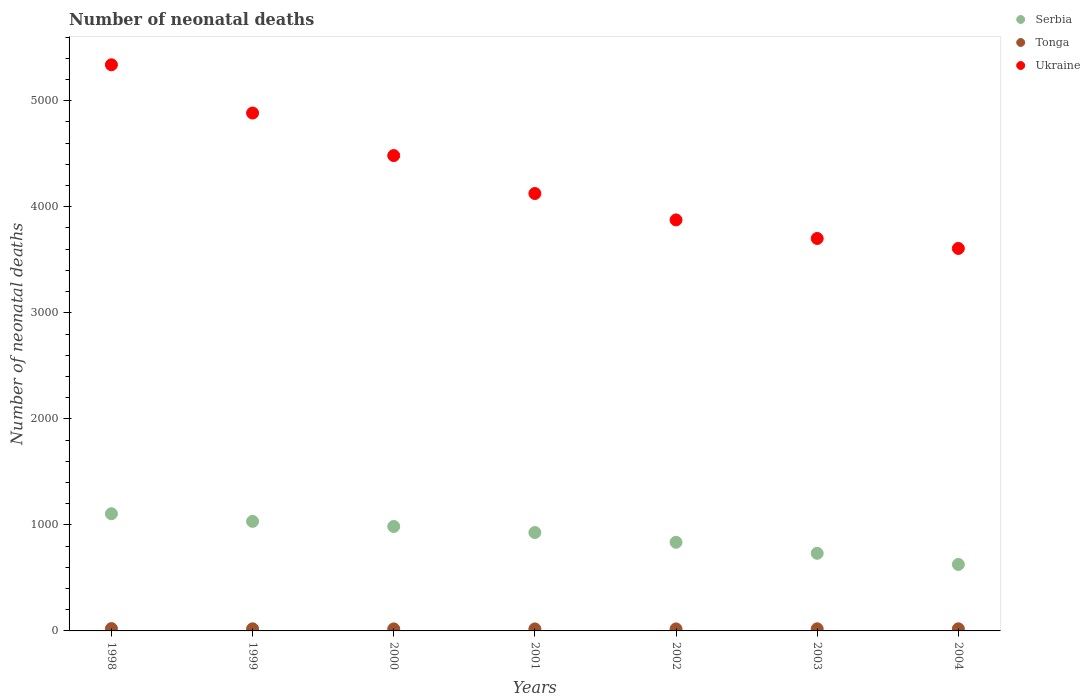How many different coloured dotlines are there?
Your answer should be very brief. 3. What is the number of neonatal deaths in in Serbia in 2001?
Your response must be concise. 928. Across all years, what is the maximum number of neonatal deaths in in Tonga?
Provide a short and direct response. 22. Across all years, what is the minimum number of neonatal deaths in in Tonga?
Offer a very short reply. 19. In which year was the number of neonatal deaths in in Ukraine maximum?
Give a very brief answer. 1998. In which year was the number of neonatal deaths in in Tonga minimum?
Your response must be concise. 2000. What is the total number of neonatal deaths in in Ukraine in the graph?
Ensure brevity in your answer.  3.00e+04. What is the difference between the number of neonatal deaths in in Ukraine in 1998 and the number of neonatal deaths in in Tonga in 2002?
Give a very brief answer. 5320. What is the average number of neonatal deaths in in Tonga per year?
Offer a very short reply. 19.86. In the year 1998, what is the difference between the number of neonatal deaths in in Tonga and number of neonatal deaths in in Serbia?
Your answer should be compact. -1083. Is the difference between the number of neonatal deaths in in Tonga in 1998 and 1999 greater than the difference between the number of neonatal deaths in in Serbia in 1998 and 1999?
Give a very brief answer. No. What is the difference between the highest and the second highest number of neonatal deaths in in Serbia?
Provide a short and direct response. 72. What is the difference between the highest and the lowest number of neonatal deaths in in Serbia?
Make the answer very short. 478. Is the number of neonatal deaths in in Serbia strictly greater than the number of neonatal deaths in in Ukraine over the years?
Ensure brevity in your answer.  No. How many dotlines are there?
Give a very brief answer. 3. How many years are there in the graph?
Your answer should be compact. 7. Are the values on the major ticks of Y-axis written in scientific E-notation?
Provide a short and direct response. No. Where does the legend appear in the graph?
Give a very brief answer. Top right. What is the title of the graph?
Keep it short and to the point. Number of neonatal deaths. Does "Lower middle income" appear as one of the legend labels in the graph?
Your answer should be compact. No. What is the label or title of the Y-axis?
Your response must be concise. Number of neonatal deaths. What is the Number of neonatal deaths of Serbia in 1998?
Offer a terse response. 1105. What is the Number of neonatal deaths of Ukraine in 1998?
Your answer should be very brief. 5339. What is the Number of neonatal deaths of Serbia in 1999?
Give a very brief answer. 1033. What is the Number of neonatal deaths of Tonga in 1999?
Keep it short and to the point. 20. What is the Number of neonatal deaths in Ukraine in 1999?
Your answer should be very brief. 4884. What is the Number of neonatal deaths of Serbia in 2000?
Offer a terse response. 985. What is the Number of neonatal deaths of Ukraine in 2000?
Provide a short and direct response. 4483. What is the Number of neonatal deaths in Serbia in 2001?
Keep it short and to the point. 928. What is the Number of neonatal deaths in Ukraine in 2001?
Offer a very short reply. 4125. What is the Number of neonatal deaths of Serbia in 2002?
Your response must be concise. 836. What is the Number of neonatal deaths of Tonga in 2002?
Your answer should be very brief. 19. What is the Number of neonatal deaths in Ukraine in 2002?
Offer a very short reply. 3876. What is the Number of neonatal deaths in Serbia in 2003?
Offer a terse response. 732. What is the Number of neonatal deaths of Tonga in 2003?
Keep it short and to the point. 20. What is the Number of neonatal deaths of Ukraine in 2003?
Ensure brevity in your answer.  3701. What is the Number of neonatal deaths in Serbia in 2004?
Your answer should be very brief. 627. What is the Number of neonatal deaths of Ukraine in 2004?
Keep it short and to the point. 3607. Across all years, what is the maximum Number of neonatal deaths of Serbia?
Your response must be concise. 1105. Across all years, what is the maximum Number of neonatal deaths of Tonga?
Make the answer very short. 22. Across all years, what is the maximum Number of neonatal deaths in Ukraine?
Ensure brevity in your answer.  5339. Across all years, what is the minimum Number of neonatal deaths of Serbia?
Ensure brevity in your answer.  627. Across all years, what is the minimum Number of neonatal deaths in Tonga?
Make the answer very short. 19. Across all years, what is the minimum Number of neonatal deaths in Ukraine?
Make the answer very short. 3607. What is the total Number of neonatal deaths of Serbia in the graph?
Provide a short and direct response. 6246. What is the total Number of neonatal deaths in Tonga in the graph?
Your answer should be very brief. 139. What is the total Number of neonatal deaths of Ukraine in the graph?
Make the answer very short. 3.00e+04. What is the difference between the Number of neonatal deaths of Ukraine in 1998 and that in 1999?
Make the answer very short. 455. What is the difference between the Number of neonatal deaths in Serbia in 1998 and that in 2000?
Provide a succinct answer. 120. What is the difference between the Number of neonatal deaths in Tonga in 1998 and that in 2000?
Offer a very short reply. 3. What is the difference between the Number of neonatal deaths in Ukraine in 1998 and that in 2000?
Offer a very short reply. 856. What is the difference between the Number of neonatal deaths of Serbia in 1998 and that in 2001?
Make the answer very short. 177. What is the difference between the Number of neonatal deaths in Ukraine in 1998 and that in 2001?
Your answer should be very brief. 1214. What is the difference between the Number of neonatal deaths in Serbia in 1998 and that in 2002?
Keep it short and to the point. 269. What is the difference between the Number of neonatal deaths in Tonga in 1998 and that in 2002?
Keep it short and to the point. 3. What is the difference between the Number of neonatal deaths of Ukraine in 1998 and that in 2002?
Ensure brevity in your answer.  1463. What is the difference between the Number of neonatal deaths of Serbia in 1998 and that in 2003?
Your answer should be very brief. 373. What is the difference between the Number of neonatal deaths in Tonga in 1998 and that in 2003?
Give a very brief answer. 2. What is the difference between the Number of neonatal deaths of Ukraine in 1998 and that in 2003?
Give a very brief answer. 1638. What is the difference between the Number of neonatal deaths of Serbia in 1998 and that in 2004?
Keep it short and to the point. 478. What is the difference between the Number of neonatal deaths in Ukraine in 1998 and that in 2004?
Offer a very short reply. 1732. What is the difference between the Number of neonatal deaths of Serbia in 1999 and that in 2000?
Give a very brief answer. 48. What is the difference between the Number of neonatal deaths in Ukraine in 1999 and that in 2000?
Offer a very short reply. 401. What is the difference between the Number of neonatal deaths of Serbia in 1999 and that in 2001?
Keep it short and to the point. 105. What is the difference between the Number of neonatal deaths of Tonga in 1999 and that in 2001?
Ensure brevity in your answer.  1. What is the difference between the Number of neonatal deaths in Ukraine in 1999 and that in 2001?
Keep it short and to the point. 759. What is the difference between the Number of neonatal deaths in Serbia in 1999 and that in 2002?
Your answer should be compact. 197. What is the difference between the Number of neonatal deaths in Tonga in 1999 and that in 2002?
Your response must be concise. 1. What is the difference between the Number of neonatal deaths of Ukraine in 1999 and that in 2002?
Keep it short and to the point. 1008. What is the difference between the Number of neonatal deaths of Serbia in 1999 and that in 2003?
Provide a short and direct response. 301. What is the difference between the Number of neonatal deaths in Tonga in 1999 and that in 2003?
Provide a succinct answer. 0. What is the difference between the Number of neonatal deaths in Ukraine in 1999 and that in 2003?
Offer a very short reply. 1183. What is the difference between the Number of neonatal deaths in Serbia in 1999 and that in 2004?
Keep it short and to the point. 406. What is the difference between the Number of neonatal deaths in Tonga in 1999 and that in 2004?
Keep it short and to the point. 0. What is the difference between the Number of neonatal deaths in Ukraine in 1999 and that in 2004?
Give a very brief answer. 1277. What is the difference between the Number of neonatal deaths in Serbia in 2000 and that in 2001?
Give a very brief answer. 57. What is the difference between the Number of neonatal deaths in Tonga in 2000 and that in 2001?
Provide a succinct answer. 0. What is the difference between the Number of neonatal deaths of Ukraine in 2000 and that in 2001?
Provide a short and direct response. 358. What is the difference between the Number of neonatal deaths in Serbia in 2000 and that in 2002?
Provide a short and direct response. 149. What is the difference between the Number of neonatal deaths of Ukraine in 2000 and that in 2002?
Your answer should be compact. 607. What is the difference between the Number of neonatal deaths of Serbia in 2000 and that in 2003?
Offer a terse response. 253. What is the difference between the Number of neonatal deaths of Tonga in 2000 and that in 2003?
Your response must be concise. -1. What is the difference between the Number of neonatal deaths in Ukraine in 2000 and that in 2003?
Provide a short and direct response. 782. What is the difference between the Number of neonatal deaths of Serbia in 2000 and that in 2004?
Ensure brevity in your answer.  358. What is the difference between the Number of neonatal deaths in Ukraine in 2000 and that in 2004?
Your answer should be very brief. 876. What is the difference between the Number of neonatal deaths in Serbia in 2001 and that in 2002?
Your answer should be very brief. 92. What is the difference between the Number of neonatal deaths in Tonga in 2001 and that in 2002?
Your answer should be very brief. 0. What is the difference between the Number of neonatal deaths in Ukraine in 2001 and that in 2002?
Give a very brief answer. 249. What is the difference between the Number of neonatal deaths in Serbia in 2001 and that in 2003?
Give a very brief answer. 196. What is the difference between the Number of neonatal deaths in Ukraine in 2001 and that in 2003?
Make the answer very short. 424. What is the difference between the Number of neonatal deaths of Serbia in 2001 and that in 2004?
Keep it short and to the point. 301. What is the difference between the Number of neonatal deaths of Ukraine in 2001 and that in 2004?
Offer a terse response. 518. What is the difference between the Number of neonatal deaths in Serbia in 2002 and that in 2003?
Your answer should be very brief. 104. What is the difference between the Number of neonatal deaths of Ukraine in 2002 and that in 2003?
Provide a succinct answer. 175. What is the difference between the Number of neonatal deaths of Serbia in 2002 and that in 2004?
Give a very brief answer. 209. What is the difference between the Number of neonatal deaths in Ukraine in 2002 and that in 2004?
Offer a very short reply. 269. What is the difference between the Number of neonatal deaths of Serbia in 2003 and that in 2004?
Give a very brief answer. 105. What is the difference between the Number of neonatal deaths of Tonga in 2003 and that in 2004?
Provide a short and direct response. 0. What is the difference between the Number of neonatal deaths of Ukraine in 2003 and that in 2004?
Provide a short and direct response. 94. What is the difference between the Number of neonatal deaths in Serbia in 1998 and the Number of neonatal deaths in Tonga in 1999?
Keep it short and to the point. 1085. What is the difference between the Number of neonatal deaths of Serbia in 1998 and the Number of neonatal deaths of Ukraine in 1999?
Provide a short and direct response. -3779. What is the difference between the Number of neonatal deaths of Tonga in 1998 and the Number of neonatal deaths of Ukraine in 1999?
Ensure brevity in your answer.  -4862. What is the difference between the Number of neonatal deaths of Serbia in 1998 and the Number of neonatal deaths of Tonga in 2000?
Make the answer very short. 1086. What is the difference between the Number of neonatal deaths in Serbia in 1998 and the Number of neonatal deaths in Ukraine in 2000?
Your answer should be compact. -3378. What is the difference between the Number of neonatal deaths in Tonga in 1998 and the Number of neonatal deaths in Ukraine in 2000?
Keep it short and to the point. -4461. What is the difference between the Number of neonatal deaths of Serbia in 1998 and the Number of neonatal deaths of Tonga in 2001?
Make the answer very short. 1086. What is the difference between the Number of neonatal deaths in Serbia in 1998 and the Number of neonatal deaths in Ukraine in 2001?
Provide a short and direct response. -3020. What is the difference between the Number of neonatal deaths of Tonga in 1998 and the Number of neonatal deaths of Ukraine in 2001?
Provide a short and direct response. -4103. What is the difference between the Number of neonatal deaths of Serbia in 1998 and the Number of neonatal deaths of Tonga in 2002?
Make the answer very short. 1086. What is the difference between the Number of neonatal deaths of Serbia in 1998 and the Number of neonatal deaths of Ukraine in 2002?
Your answer should be compact. -2771. What is the difference between the Number of neonatal deaths of Tonga in 1998 and the Number of neonatal deaths of Ukraine in 2002?
Give a very brief answer. -3854. What is the difference between the Number of neonatal deaths in Serbia in 1998 and the Number of neonatal deaths in Tonga in 2003?
Your answer should be compact. 1085. What is the difference between the Number of neonatal deaths in Serbia in 1998 and the Number of neonatal deaths in Ukraine in 2003?
Offer a terse response. -2596. What is the difference between the Number of neonatal deaths in Tonga in 1998 and the Number of neonatal deaths in Ukraine in 2003?
Your answer should be very brief. -3679. What is the difference between the Number of neonatal deaths of Serbia in 1998 and the Number of neonatal deaths of Tonga in 2004?
Provide a succinct answer. 1085. What is the difference between the Number of neonatal deaths of Serbia in 1998 and the Number of neonatal deaths of Ukraine in 2004?
Keep it short and to the point. -2502. What is the difference between the Number of neonatal deaths in Tonga in 1998 and the Number of neonatal deaths in Ukraine in 2004?
Your answer should be very brief. -3585. What is the difference between the Number of neonatal deaths in Serbia in 1999 and the Number of neonatal deaths in Tonga in 2000?
Keep it short and to the point. 1014. What is the difference between the Number of neonatal deaths in Serbia in 1999 and the Number of neonatal deaths in Ukraine in 2000?
Make the answer very short. -3450. What is the difference between the Number of neonatal deaths in Tonga in 1999 and the Number of neonatal deaths in Ukraine in 2000?
Offer a terse response. -4463. What is the difference between the Number of neonatal deaths of Serbia in 1999 and the Number of neonatal deaths of Tonga in 2001?
Keep it short and to the point. 1014. What is the difference between the Number of neonatal deaths of Serbia in 1999 and the Number of neonatal deaths of Ukraine in 2001?
Offer a very short reply. -3092. What is the difference between the Number of neonatal deaths of Tonga in 1999 and the Number of neonatal deaths of Ukraine in 2001?
Offer a very short reply. -4105. What is the difference between the Number of neonatal deaths in Serbia in 1999 and the Number of neonatal deaths in Tonga in 2002?
Provide a succinct answer. 1014. What is the difference between the Number of neonatal deaths of Serbia in 1999 and the Number of neonatal deaths of Ukraine in 2002?
Make the answer very short. -2843. What is the difference between the Number of neonatal deaths of Tonga in 1999 and the Number of neonatal deaths of Ukraine in 2002?
Offer a very short reply. -3856. What is the difference between the Number of neonatal deaths of Serbia in 1999 and the Number of neonatal deaths of Tonga in 2003?
Ensure brevity in your answer.  1013. What is the difference between the Number of neonatal deaths in Serbia in 1999 and the Number of neonatal deaths in Ukraine in 2003?
Provide a short and direct response. -2668. What is the difference between the Number of neonatal deaths in Tonga in 1999 and the Number of neonatal deaths in Ukraine in 2003?
Provide a short and direct response. -3681. What is the difference between the Number of neonatal deaths in Serbia in 1999 and the Number of neonatal deaths in Tonga in 2004?
Keep it short and to the point. 1013. What is the difference between the Number of neonatal deaths of Serbia in 1999 and the Number of neonatal deaths of Ukraine in 2004?
Your response must be concise. -2574. What is the difference between the Number of neonatal deaths of Tonga in 1999 and the Number of neonatal deaths of Ukraine in 2004?
Provide a short and direct response. -3587. What is the difference between the Number of neonatal deaths of Serbia in 2000 and the Number of neonatal deaths of Tonga in 2001?
Provide a succinct answer. 966. What is the difference between the Number of neonatal deaths in Serbia in 2000 and the Number of neonatal deaths in Ukraine in 2001?
Keep it short and to the point. -3140. What is the difference between the Number of neonatal deaths in Tonga in 2000 and the Number of neonatal deaths in Ukraine in 2001?
Ensure brevity in your answer.  -4106. What is the difference between the Number of neonatal deaths in Serbia in 2000 and the Number of neonatal deaths in Tonga in 2002?
Keep it short and to the point. 966. What is the difference between the Number of neonatal deaths of Serbia in 2000 and the Number of neonatal deaths of Ukraine in 2002?
Give a very brief answer. -2891. What is the difference between the Number of neonatal deaths of Tonga in 2000 and the Number of neonatal deaths of Ukraine in 2002?
Offer a terse response. -3857. What is the difference between the Number of neonatal deaths of Serbia in 2000 and the Number of neonatal deaths of Tonga in 2003?
Ensure brevity in your answer.  965. What is the difference between the Number of neonatal deaths of Serbia in 2000 and the Number of neonatal deaths of Ukraine in 2003?
Provide a succinct answer. -2716. What is the difference between the Number of neonatal deaths of Tonga in 2000 and the Number of neonatal deaths of Ukraine in 2003?
Your answer should be compact. -3682. What is the difference between the Number of neonatal deaths of Serbia in 2000 and the Number of neonatal deaths of Tonga in 2004?
Ensure brevity in your answer.  965. What is the difference between the Number of neonatal deaths of Serbia in 2000 and the Number of neonatal deaths of Ukraine in 2004?
Offer a very short reply. -2622. What is the difference between the Number of neonatal deaths in Tonga in 2000 and the Number of neonatal deaths in Ukraine in 2004?
Your answer should be compact. -3588. What is the difference between the Number of neonatal deaths in Serbia in 2001 and the Number of neonatal deaths in Tonga in 2002?
Your answer should be compact. 909. What is the difference between the Number of neonatal deaths in Serbia in 2001 and the Number of neonatal deaths in Ukraine in 2002?
Your response must be concise. -2948. What is the difference between the Number of neonatal deaths of Tonga in 2001 and the Number of neonatal deaths of Ukraine in 2002?
Your response must be concise. -3857. What is the difference between the Number of neonatal deaths in Serbia in 2001 and the Number of neonatal deaths in Tonga in 2003?
Your response must be concise. 908. What is the difference between the Number of neonatal deaths of Serbia in 2001 and the Number of neonatal deaths of Ukraine in 2003?
Provide a succinct answer. -2773. What is the difference between the Number of neonatal deaths in Tonga in 2001 and the Number of neonatal deaths in Ukraine in 2003?
Your response must be concise. -3682. What is the difference between the Number of neonatal deaths of Serbia in 2001 and the Number of neonatal deaths of Tonga in 2004?
Offer a very short reply. 908. What is the difference between the Number of neonatal deaths of Serbia in 2001 and the Number of neonatal deaths of Ukraine in 2004?
Ensure brevity in your answer.  -2679. What is the difference between the Number of neonatal deaths in Tonga in 2001 and the Number of neonatal deaths in Ukraine in 2004?
Provide a short and direct response. -3588. What is the difference between the Number of neonatal deaths of Serbia in 2002 and the Number of neonatal deaths of Tonga in 2003?
Your answer should be very brief. 816. What is the difference between the Number of neonatal deaths in Serbia in 2002 and the Number of neonatal deaths in Ukraine in 2003?
Provide a short and direct response. -2865. What is the difference between the Number of neonatal deaths in Tonga in 2002 and the Number of neonatal deaths in Ukraine in 2003?
Provide a short and direct response. -3682. What is the difference between the Number of neonatal deaths of Serbia in 2002 and the Number of neonatal deaths of Tonga in 2004?
Your answer should be very brief. 816. What is the difference between the Number of neonatal deaths in Serbia in 2002 and the Number of neonatal deaths in Ukraine in 2004?
Offer a very short reply. -2771. What is the difference between the Number of neonatal deaths in Tonga in 2002 and the Number of neonatal deaths in Ukraine in 2004?
Provide a succinct answer. -3588. What is the difference between the Number of neonatal deaths of Serbia in 2003 and the Number of neonatal deaths of Tonga in 2004?
Provide a short and direct response. 712. What is the difference between the Number of neonatal deaths in Serbia in 2003 and the Number of neonatal deaths in Ukraine in 2004?
Your answer should be compact. -2875. What is the difference between the Number of neonatal deaths of Tonga in 2003 and the Number of neonatal deaths of Ukraine in 2004?
Your response must be concise. -3587. What is the average Number of neonatal deaths in Serbia per year?
Your response must be concise. 892.29. What is the average Number of neonatal deaths of Tonga per year?
Your response must be concise. 19.86. What is the average Number of neonatal deaths in Ukraine per year?
Your answer should be compact. 4287.86. In the year 1998, what is the difference between the Number of neonatal deaths of Serbia and Number of neonatal deaths of Tonga?
Offer a very short reply. 1083. In the year 1998, what is the difference between the Number of neonatal deaths of Serbia and Number of neonatal deaths of Ukraine?
Give a very brief answer. -4234. In the year 1998, what is the difference between the Number of neonatal deaths of Tonga and Number of neonatal deaths of Ukraine?
Provide a short and direct response. -5317. In the year 1999, what is the difference between the Number of neonatal deaths in Serbia and Number of neonatal deaths in Tonga?
Provide a short and direct response. 1013. In the year 1999, what is the difference between the Number of neonatal deaths in Serbia and Number of neonatal deaths in Ukraine?
Ensure brevity in your answer.  -3851. In the year 1999, what is the difference between the Number of neonatal deaths of Tonga and Number of neonatal deaths of Ukraine?
Ensure brevity in your answer.  -4864. In the year 2000, what is the difference between the Number of neonatal deaths of Serbia and Number of neonatal deaths of Tonga?
Your response must be concise. 966. In the year 2000, what is the difference between the Number of neonatal deaths in Serbia and Number of neonatal deaths in Ukraine?
Provide a succinct answer. -3498. In the year 2000, what is the difference between the Number of neonatal deaths in Tonga and Number of neonatal deaths in Ukraine?
Provide a succinct answer. -4464. In the year 2001, what is the difference between the Number of neonatal deaths of Serbia and Number of neonatal deaths of Tonga?
Your answer should be compact. 909. In the year 2001, what is the difference between the Number of neonatal deaths of Serbia and Number of neonatal deaths of Ukraine?
Offer a terse response. -3197. In the year 2001, what is the difference between the Number of neonatal deaths in Tonga and Number of neonatal deaths in Ukraine?
Your answer should be very brief. -4106. In the year 2002, what is the difference between the Number of neonatal deaths in Serbia and Number of neonatal deaths in Tonga?
Give a very brief answer. 817. In the year 2002, what is the difference between the Number of neonatal deaths in Serbia and Number of neonatal deaths in Ukraine?
Offer a terse response. -3040. In the year 2002, what is the difference between the Number of neonatal deaths in Tonga and Number of neonatal deaths in Ukraine?
Provide a short and direct response. -3857. In the year 2003, what is the difference between the Number of neonatal deaths in Serbia and Number of neonatal deaths in Tonga?
Your answer should be compact. 712. In the year 2003, what is the difference between the Number of neonatal deaths of Serbia and Number of neonatal deaths of Ukraine?
Give a very brief answer. -2969. In the year 2003, what is the difference between the Number of neonatal deaths of Tonga and Number of neonatal deaths of Ukraine?
Ensure brevity in your answer.  -3681. In the year 2004, what is the difference between the Number of neonatal deaths in Serbia and Number of neonatal deaths in Tonga?
Provide a succinct answer. 607. In the year 2004, what is the difference between the Number of neonatal deaths in Serbia and Number of neonatal deaths in Ukraine?
Ensure brevity in your answer.  -2980. In the year 2004, what is the difference between the Number of neonatal deaths of Tonga and Number of neonatal deaths of Ukraine?
Your answer should be compact. -3587. What is the ratio of the Number of neonatal deaths of Serbia in 1998 to that in 1999?
Offer a very short reply. 1.07. What is the ratio of the Number of neonatal deaths of Tonga in 1998 to that in 1999?
Offer a terse response. 1.1. What is the ratio of the Number of neonatal deaths of Ukraine in 1998 to that in 1999?
Provide a succinct answer. 1.09. What is the ratio of the Number of neonatal deaths in Serbia in 1998 to that in 2000?
Your response must be concise. 1.12. What is the ratio of the Number of neonatal deaths of Tonga in 1998 to that in 2000?
Provide a short and direct response. 1.16. What is the ratio of the Number of neonatal deaths of Ukraine in 1998 to that in 2000?
Give a very brief answer. 1.19. What is the ratio of the Number of neonatal deaths of Serbia in 1998 to that in 2001?
Keep it short and to the point. 1.19. What is the ratio of the Number of neonatal deaths in Tonga in 1998 to that in 2001?
Offer a very short reply. 1.16. What is the ratio of the Number of neonatal deaths in Ukraine in 1998 to that in 2001?
Keep it short and to the point. 1.29. What is the ratio of the Number of neonatal deaths in Serbia in 1998 to that in 2002?
Offer a terse response. 1.32. What is the ratio of the Number of neonatal deaths of Tonga in 1998 to that in 2002?
Give a very brief answer. 1.16. What is the ratio of the Number of neonatal deaths of Ukraine in 1998 to that in 2002?
Offer a terse response. 1.38. What is the ratio of the Number of neonatal deaths of Serbia in 1998 to that in 2003?
Keep it short and to the point. 1.51. What is the ratio of the Number of neonatal deaths in Tonga in 1998 to that in 2003?
Provide a short and direct response. 1.1. What is the ratio of the Number of neonatal deaths of Ukraine in 1998 to that in 2003?
Offer a very short reply. 1.44. What is the ratio of the Number of neonatal deaths in Serbia in 1998 to that in 2004?
Give a very brief answer. 1.76. What is the ratio of the Number of neonatal deaths in Tonga in 1998 to that in 2004?
Your response must be concise. 1.1. What is the ratio of the Number of neonatal deaths of Ukraine in 1998 to that in 2004?
Make the answer very short. 1.48. What is the ratio of the Number of neonatal deaths in Serbia in 1999 to that in 2000?
Provide a short and direct response. 1.05. What is the ratio of the Number of neonatal deaths of Tonga in 1999 to that in 2000?
Provide a short and direct response. 1.05. What is the ratio of the Number of neonatal deaths in Ukraine in 1999 to that in 2000?
Keep it short and to the point. 1.09. What is the ratio of the Number of neonatal deaths in Serbia in 1999 to that in 2001?
Offer a terse response. 1.11. What is the ratio of the Number of neonatal deaths in Tonga in 1999 to that in 2001?
Your answer should be compact. 1.05. What is the ratio of the Number of neonatal deaths of Ukraine in 1999 to that in 2001?
Keep it short and to the point. 1.18. What is the ratio of the Number of neonatal deaths of Serbia in 1999 to that in 2002?
Keep it short and to the point. 1.24. What is the ratio of the Number of neonatal deaths of Tonga in 1999 to that in 2002?
Your answer should be compact. 1.05. What is the ratio of the Number of neonatal deaths of Ukraine in 1999 to that in 2002?
Your response must be concise. 1.26. What is the ratio of the Number of neonatal deaths of Serbia in 1999 to that in 2003?
Offer a terse response. 1.41. What is the ratio of the Number of neonatal deaths of Tonga in 1999 to that in 2003?
Keep it short and to the point. 1. What is the ratio of the Number of neonatal deaths in Ukraine in 1999 to that in 2003?
Make the answer very short. 1.32. What is the ratio of the Number of neonatal deaths of Serbia in 1999 to that in 2004?
Keep it short and to the point. 1.65. What is the ratio of the Number of neonatal deaths in Tonga in 1999 to that in 2004?
Keep it short and to the point. 1. What is the ratio of the Number of neonatal deaths of Ukraine in 1999 to that in 2004?
Provide a succinct answer. 1.35. What is the ratio of the Number of neonatal deaths in Serbia in 2000 to that in 2001?
Provide a short and direct response. 1.06. What is the ratio of the Number of neonatal deaths of Ukraine in 2000 to that in 2001?
Your answer should be very brief. 1.09. What is the ratio of the Number of neonatal deaths of Serbia in 2000 to that in 2002?
Your answer should be compact. 1.18. What is the ratio of the Number of neonatal deaths in Tonga in 2000 to that in 2002?
Provide a short and direct response. 1. What is the ratio of the Number of neonatal deaths in Ukraine in 2000 to that in 2002?
Give a very brief answer. 1.16. What is the ratio of the Number of neonatal deaths in Serbia in 2000 to that in 2003?
Ensure brevity in your answer.  1.35. What is the ratio of the Number of neonatal deaths of Ukraine in 2000 to that in 2003?
Offer a terse response. 1.21. What is the ratio of the Number of neonatal deaths in Serbia in 2000 to that in 2004?
Give a very brief answer. 1.57. What is the ratio of the Number of neonatal deaths of Ukraine in 2000 to that in 2004?
Make the answer very short. 1.24. What is the ratio of the Number of neonatal deaths in Serbia in 2001 to that in 2002?
Give a very brief answer. 1.11. What is the ratio of the Number of neonatal deaths in Ukraine in 2001 to that in 2002?
Provide a short and direct response. 1.06. What is the ratio of the Number of neonatal deaths of Serbia in 2001 to that in 2003?
Offer a terse response. 1.27. What is the ratio of the Number of neonatal deaths in Ukraine in 2001 to that in 2003?
Provide a succinct answer. 1.11. What is the ratio of the Number of neonatal deaths of Serbia in 2001 to that in 2004?
Your response must be concise. 1.48. What is the ratio of the Number of neonatal deaths in Tonga in 2001 to that in 2004?
Ensure brevity in your answer.  0.95. What is the ratio of the Number of neonatal deaths of Ukraine in 2001 to that in 2004?
Your answer should be very brief. 1.14. What is the ratio of the Number of neonatal deaths in Serbia in 2002 to that in 2003?
Offer a terse response. 1.14. What is the ratio of the Number of neonatal deaths of Tonga in 2002 to that in 2003?
Offer a very short reply. 0.95. What is the ratio of the Number of neonatal deaths in Ukraine in 2002 to that in 2003?
Give a very brief answer. 1.05. What is the ratio of the Number of neonatal deaths of Ukraine in 2002 to that in 2004?
Offer a very short reply. 1.07. What is the ratio of the Number of neonatal deaths of Serbia in 2003 to that in 2004?
Provide a short and direct response. 1.17. What is the ratio of the Number of neonatal deaths of Tonga in 2003 to that in 2004?
Offer a terse response. 1. What is the ratio of the Number of neonatal deaths in Ukraine in 2003 to that in 2004?
Keep it short and to the point. 1.03. What is the difference between the highest and the second highest Number of neonatal deaths in Serbia?
Provide a short and direct response. 72. What is the difference between the highest and the second highest Number of neonatal deaths in Tonga?
Your answer should be compact. 2. What is the difference between the highest and the second highest Number of neonatal deaths of Ukraine?
Provide a short and direct response. 455. What is the difference between the highest and the lowest Number of neonatal deaths of Serbia?
Your response must be concise. 478. What is the difference between the highest and the lowest Number of neonatal deaths of Ukraine?
Keep it short and to the point. 1732. 